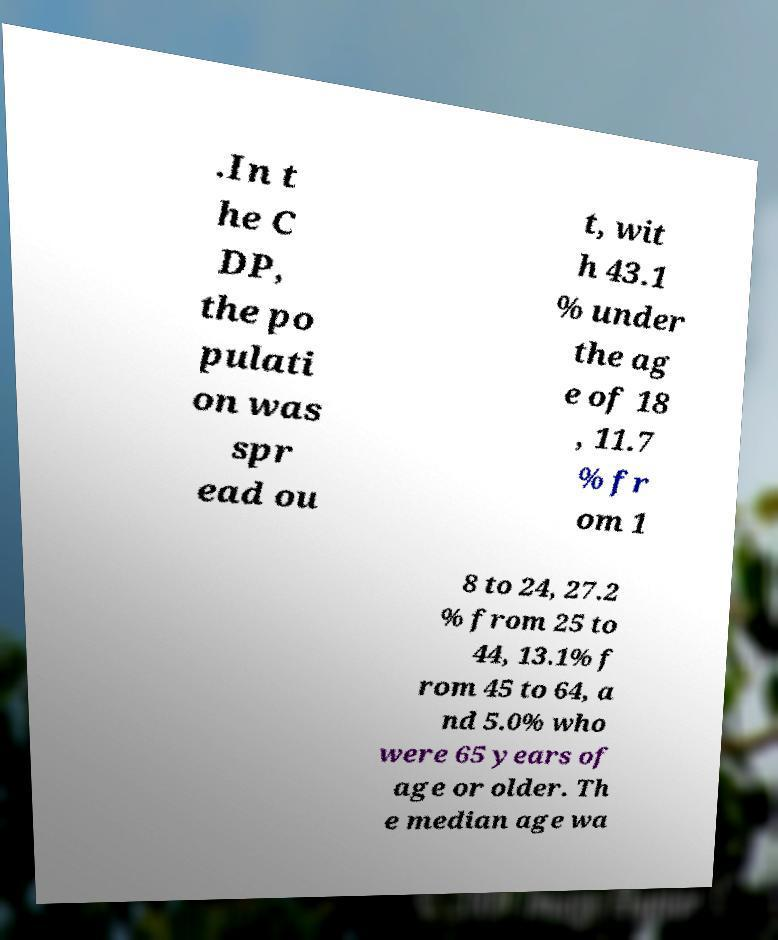Could you assist in decoding the text presented in this image and type it out clearly? .In t he C DP, the po pulati on was spr ead ou t, wit h 43.1 % under the ag e of 18 , 11.7 % fr om 1 8 to 24, 27.2 % from 25 to 44, 13.1% f rom 45 to 64, a nd 5.0% who were 65 years of age or older. Th e median age wa 